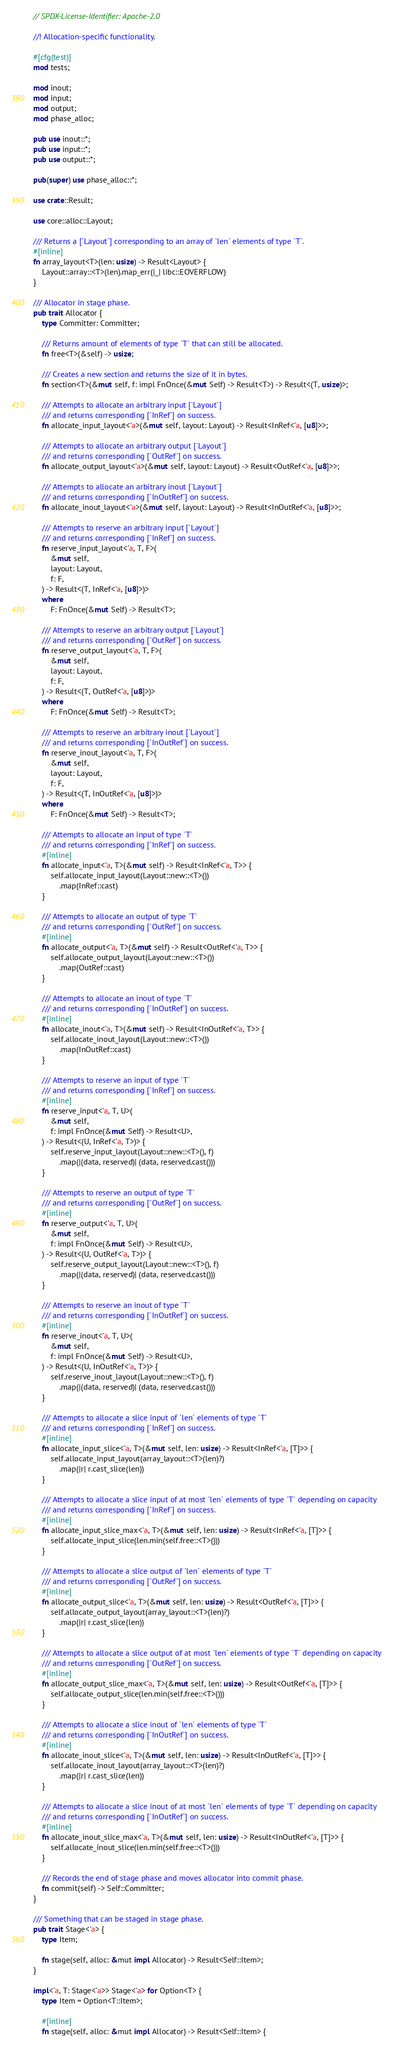<code> <loc_0><loc_0><loc_500><loc_500><_Rust_>// SPDX-License-Identifier: Apache-2.0

//! Allocation-specific functionality.

#[cfg(test)]
mod tests;

mod inout;
mod input;
mod output;
mod phase_alloc;

pub use inout::*;
pub use input::*;
pub use output::*;

pub(super) use phase_alloc::*;

use crate::Result;

use core::alloc::Layout;

/// Returns a [`Layout`] corresponding to an array of `len` elements of type `T`.
#[inline]
fn array_layout<T>(len: usize) -> Result<Layout> {
    Layout::array::<T>(len).map_err(|_| libc::EOVERFLOW)
}

/// Allocator in stage phase.
pub trait Allocator {
    type Committer: Committer;

    /// Returns amount of elements of type `T` that can still be allocated.
    fn free<T>(&self) -> usize;

    /// Creates a new section and returns the size of it in bytes.
    fn section<T>(&mut self, f: impl FnOnce(&mut Self) -> Result<T>) -> Result<(T, usize)>;

    /// Attempts to allocate an arbitrary input [`Layout`]
    /// and returns corresponding [`InRef`] on success.
    fn allocate_input_layout<'a>(&mut self, layout: Layout) -> Result<InRef<'a, [u8]>>;

    /// Attempts to allocate an arbitrary output [`Layout`]
    /// and returns corresponding [`OutRef`] on success.
    fn allocate_output_layout<'a>(&mut self, layout: Layout) -> Result<OutRef<'a, [u8]>>;

    /// Attempts to allocate an arbitrary inout [`Layout`]
    /// and returns corresponding [`InOutRef`] on success.
    fn allocate_inout_layout<'a>(&mut self, layout: Layout) -> Result<InOutRef<'a, [u8]>>;

    /// Attempts to reserve an arbitrary input [`Layout`]
    /// and returns corresponding [`InRef`] on success.
    fn reserve_input_layout<'a, T, F>(
        &mut self,
        layout: Layout,
        f: F,
    ) -> Result<(T, InRef<'a, [u8]>)>
    where
        F: FnOnce(&mut Self) -> Result<T>;

    /// Attempts to reserve an arbitrary output [`Layout`]
    /// and returns corresponding [`OutRef`] on success.
    fn reserve_output_layout<'a, T, F>(
        &mut self,
        layout: Layout,
        f: F,
    ) -> Result<(T, OutRef<'a, [u8]>)>
    where
        F: FnOnce(&mut Self) -> Result<T>;

    /// Attempts to reserve an arbitrary inout [`Layout`]
    /// and returns corresponding [`InOutRef`] on success.
    fn reserve_inout_layout<'a, T, F>(
        &mut self,
        layout: Layout,
        f: F,
    ) -> Result<(T, InOutRef<'a, [u8]>)>
    where
        F: FnOnce(&mut Self) -> Result<T>;

    /// Attempts to allocate an input of type `T`
    /// and returns corresponding [`InRef`] on success.
    #[inline]
    fn allocate_input<'a, T>(&mut self) -> Result<InRef<'a, T>> {
        self.allocate_input_layout(Layout::new::<T>())
            .map(InRef::cast)
    }

    /// Attempts to allocate an output of type `T`
    /// and returns corresponding [`OutRef`] on success.
    #[inline]
    fn allocate_output<'a, T>(&mut self) -> Result<OutRef<'a, T>> {
        self.allocate_output_layout(Layout::new::<T>())
            .map(OutRef::cast)
    }

    /// Attempts to allocate an inout of type `T`
    /// and returns corresponding [`InOutRef`] on success.
    #[inline]
    fn allocate_inout<'a, T>(&mut self) -> Result<InOutRef<'a, T>> {
        self.allocate_inout_layout(Layout::new::<T>())
            .map(InOutRef::cast)
    }

    /// Attempts to reserve an input of type `T`
    /// and returns corresponding [`InRef`] on success.
    #[inline]
    fn reserve_input<'a, T, U>(
        &mut self,
        f: impl FnOnce(&mut Self) -> Result<U>,
    ) -> Result<(U, InRef<'a, T>)> {
        self.reserve_input_layout(Layout::new::<T>(), f)
            .map(|(data, reserved)| (data, reserved.cast()))
    }

    /// Attempts to reserve an output of type `T`
    /// and returns corresponding [`OutRef`] on success.
    #[inline]
    fn reserve_output<'a, T, U>(
        &mut self,
        f: impl FnOnce(&mut Self) -> Result<U>,
    ) -> Result<(U, OutRef<'a, T>)> {
        self.reserve_output_layout(Layout::new::<T>(), f)
            .map(|(data, reserved)| (data, reserved.cast()))
    }

    /// Attempts to reserve an inout of type `T`
    /// and returns corresponding [`InOutRef`] on success.
    #[inline]
    fn reserve_inout<'a, T, U>(
        &mut self,
        f: impl FnOnce(&mut Self) -> Result<U>,
    ) -> Result<(U, InOutRef<'a, T>)> {
        self.reserve_inout_layout(Layout::new::<T>(), f)
            .map(|(data, reserved)| (data, reserved.cast()))
    }

    /// Attempts to allocate a slice input of `len` elements of type `T`
    /// and returns corresponding [`InRef`] on success.
    #[inline]
    fn allocate_input_slice<'a, T>(&mut self, len: usize) -> Result<InRef<'a, [T]>> {
        self.allocate_input_layout(array_layout::<T>(len)?)
            .map(|r| r.cast_slice(len))
    }

    /// Attempts to allocate a slice input of at most `len` elements of type `T` depending on capacity
    /// and returns corresponding [`InRef`] on success.
    #[inline]
    fn allocate_input_slice_max<'a, T>(&mut self, len: usize) -> Result<InRef<'a, [T]>> {
        self.allocate_input_slice(len.min(self.free::<T>()))
    }

    /// Attempts to allocate a slice output of `len` elements of type `T`
    /// and returns corresponding [`OutRef`] on success.
    #[inline]
    fn allocate_output_slice<'a, T>(&mut self, len: usize) -> Result<OutRef<'a, [T]>> {
        self.allocate_output_layout(array_layout::<T>(len)?)
            .map(|r| r.cast_slice(len))
    }

    /// Attempts to allocate a slice output of at most `len` elements of type `T` depending on capacity
    /// and returns corresponding [`OutRef`] on success.
    #[inline]
    fn allocate_output_slice_max<'a, T>(&mut self, len: usize) -> Result<OutRef<'a, [T]>> {
        self.allocate_output_slice(len.min(self.free::<T>()))
    }

    /// Attempts to allocate a slice inout of `len` elements of type `T`
    /// and returns corresponding [`InOutRef`] on success.
    #[inline]
    fn allocate_inout_slice<'a, T>(&mut self, len: usize) -> Result<InOutRef<'a, [T]>> {
        self.allocate_inout_layout(array_layout::<T>(len)?)
            .map(|r| r.cast_slice(len))
    }

    /// Attempts to allocate a slice inout of at most `len` elements of type `T` depending on capacity
    /// and returns corresponding [`InOutRef`] on success.
    #[inline]
    fn allocate_inout_slice_max<'a, T>(&mut self, len: usize) -> Result<InOutRef<'a, [T]>> {
        self.allocate_inout_slice(len.min(self.free::<T>()))
    }

    /// Records the end of stage phase and moves allocator into commit phase.
    fn commit(self) -> Self::Committer;
}

/// Something that can be staged in stage phase.
pub trait Stage<'a> {
    type Item;

    fn stage(self, alloc: &mut impl Allocator) -> Result<Self::Item>;
}

impl<'a, T: Stage<'a>> Stage<'a> for Option<T> {
    type Item = Option<T::Item>;

    #[inline]
    fn stage(self, alloc: &mut impl Allocator) -> Result<Self::Item> {</code> 